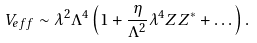Convert formula to latex. <formula><loc_0><loc_0><loc_500><loc_500>V _ { e f f } \sim \lambda ^ { 2 } \Lambda ^ { 4 } \left ( 1 + \frac { \eta } { \Lambda ^ { 2 } } \lambda ^ { 4 } Z Z ^ { * } + \dots \right ) .</formula> 